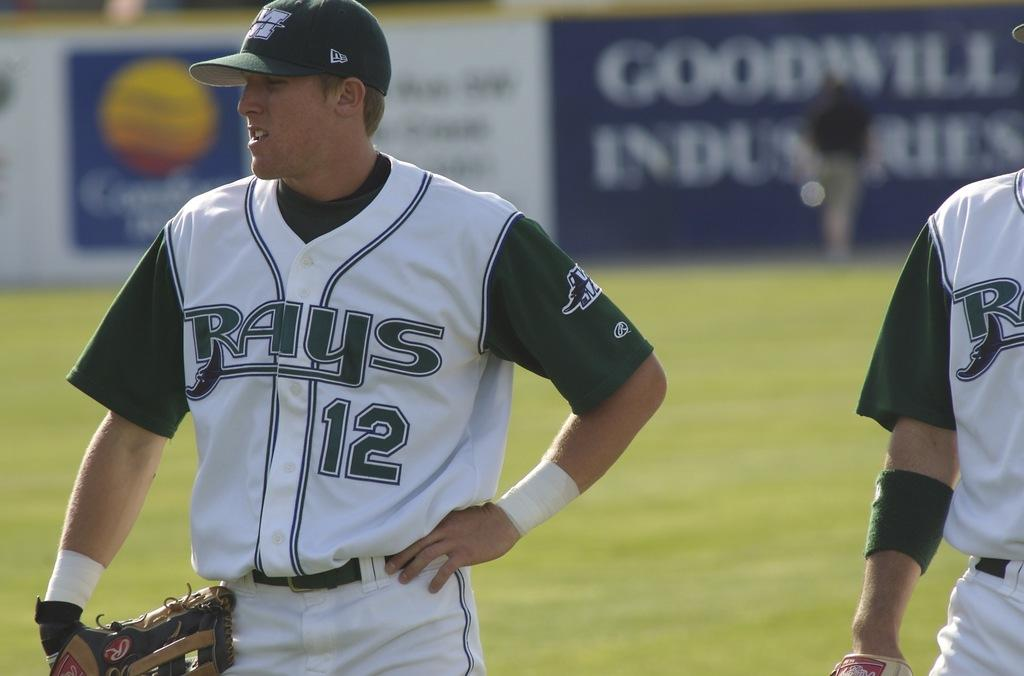How many people are in the image? There are a few people in the image. What is the ground covered with? The ground is covered with grass. What can be seen in the background of the image? There is a board with an image and text in the background. What type of pie is being served by the maid in the image? There is no maid or pie present in the image. How many icicles are hanging from the board in the background? There are no icicles present in the image; the board has an image and text. 